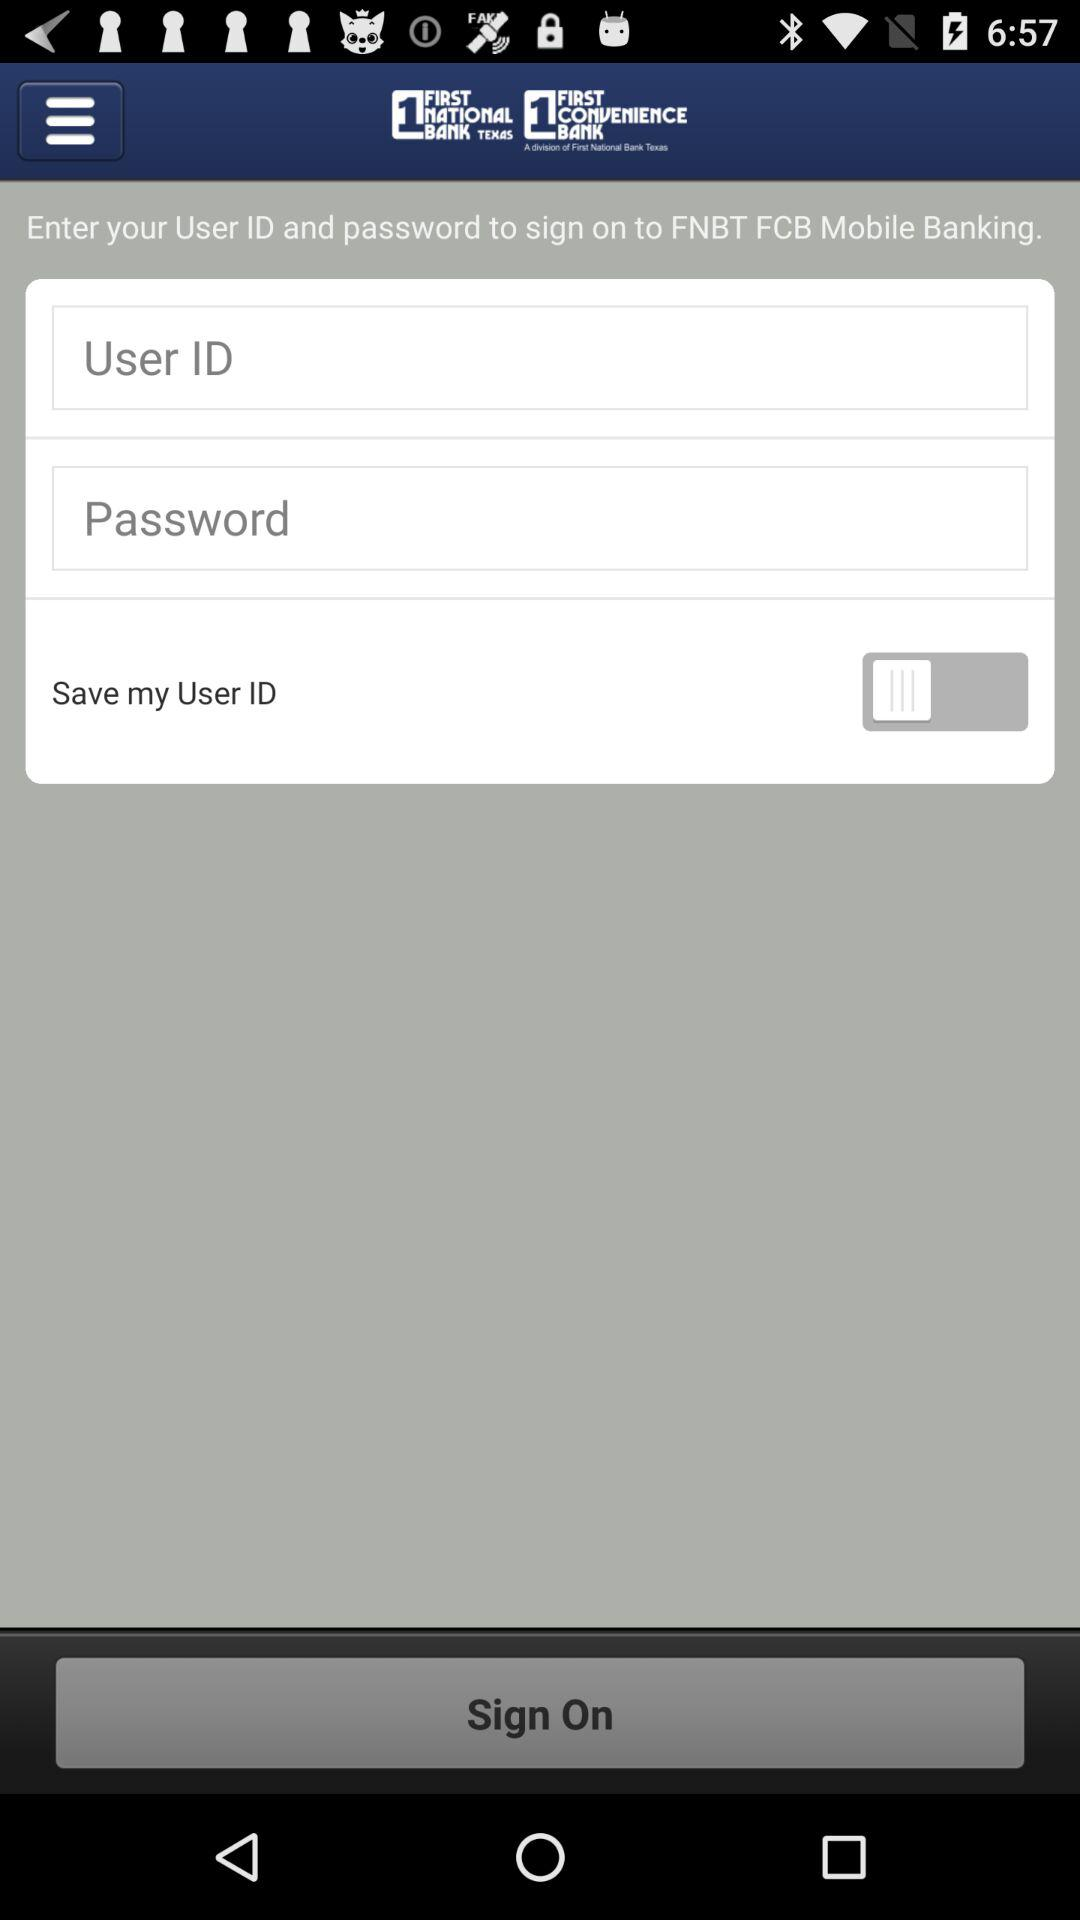What is the app name? The app name is "FNBT FCB Mobile Banking". 